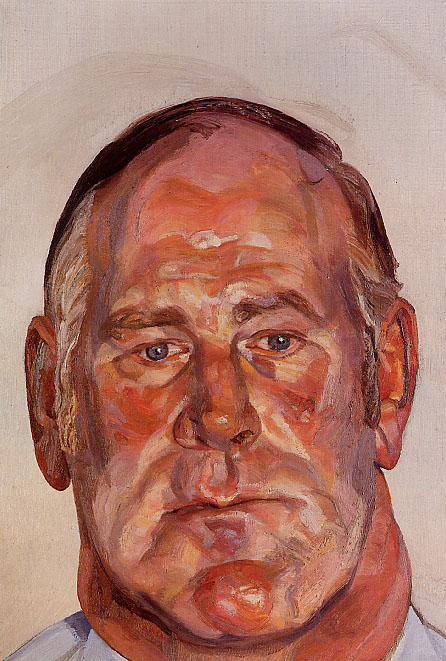Who might this man be and what could he be thinking about? While the identity of the man in the painting is not specified, we can imagine that he might be an individual deeply lost in thought. His closed eyes suggest he could be reflecting on past experiences, contemplating future decisions, or simply finding a moment of peace amidst chaos. The expressionist style of the portrait amplifies this introspection, allowing viewers to feel the intensity of his inner world as conveyed by the vibrant colors and dynamic brushstrokes. 